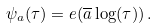<formula> <loc_0><loc_0><loc_500><loc_500>\psi _ { a } ( \tau ) = e ( \overline { a } \log ( \tau ) ) \, .</formula> 